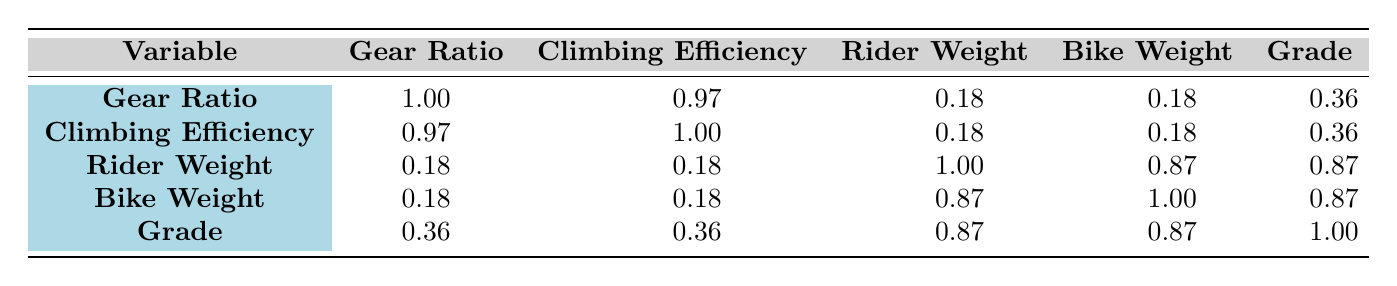What is the correlation coefficient between Gear Ratio and Climbing Efficiency? From the table, the correlation coefficient between the Gear Ratio and Climbing Efficiency is 0.97, which indicates a strong positive relationship.
Answer: 0.97 Is there a strong correlation between Rider Weight and Bike Weight? The correlation coefficient between Rider Weight and Bike Weight is 0.87, indicating a strong positive correlation between these two variables.
Answer: Yes What is the correlation coefficient between Grade and Climbing Efficiency? According to the table, the correlation coefficient between Grade and Climbing Efficiency is 0.36, suggesting a low positive correlation.
Answer: 0.36 What is the average correlation coefficient of all variables with Gear Ratio? The correlation coefficients for Gear Ratio with other variables are 1.00 (itself), 0.97 (Climbing Efficiency), 0.18 (Rider Weight), 0.18 (Bike Weight), and 0.36 (Grade). The sum of these coefficients is 2.69. Since there are 4 comparisons (excluding itself), the average is 2.69/4 = 0.6725.
Answer: 0.6725 Is the correlation between Climbing Efficiency and Bike Weight negative or positive? The correlation coefficient between Climbing Efficiency and Bike Weight is 0.18; thus, it's a positive correlation, albeit weak.
Answer: Positive 